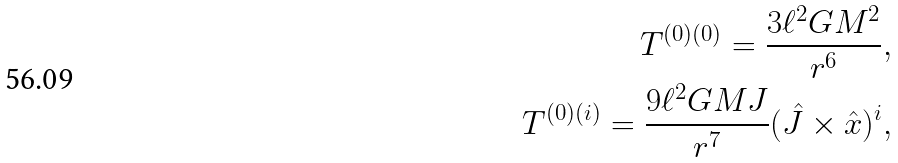<formula> <loc_0><loc_0><loc_500><loc_500>T ^ { ( 0 ) ( 0 ) } = \frac { 3 \ell ^ { 2 } G M ^ { 2 } } { r ^ { 6 } } , \\ T ^ { ( 0 ) ( i ) } = \frac { 9 \ell ^ { 2 } G M J } { r ^ { 7 } } ( { \hat { J } } \times { \hat { x } } ) ^ { i } ,</formula> 